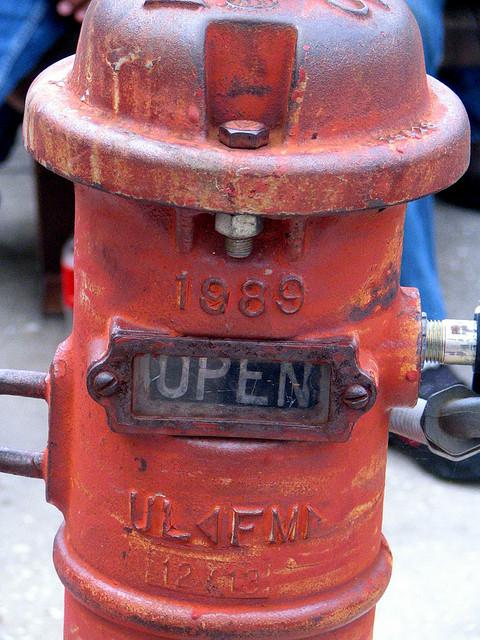What do the white letters say?
Answer briefly. Open. What color is the part?
Write a very short answer. Red. What year is seen?
Keep it brief. 1989. 